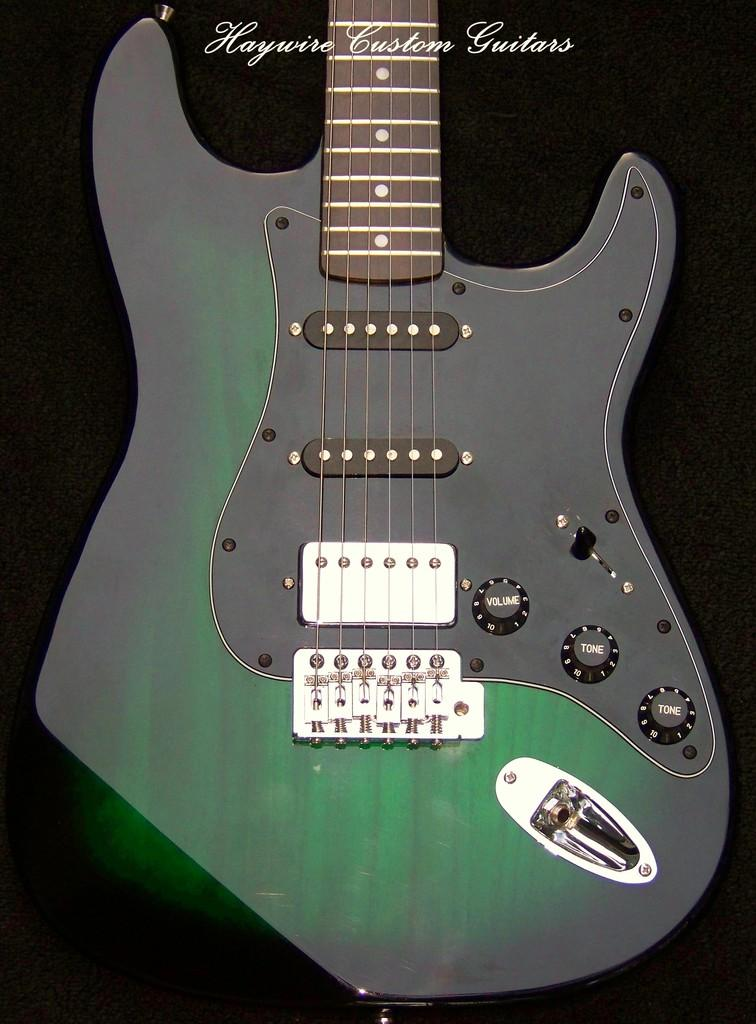What musical instrument is present in the image? There is a guitar in the image. What color is the guitar? The guitar is green in color. Where is the rabbit sitting on the guitar in the image? There is no rabbit present in the image; it only features a green guitar. 